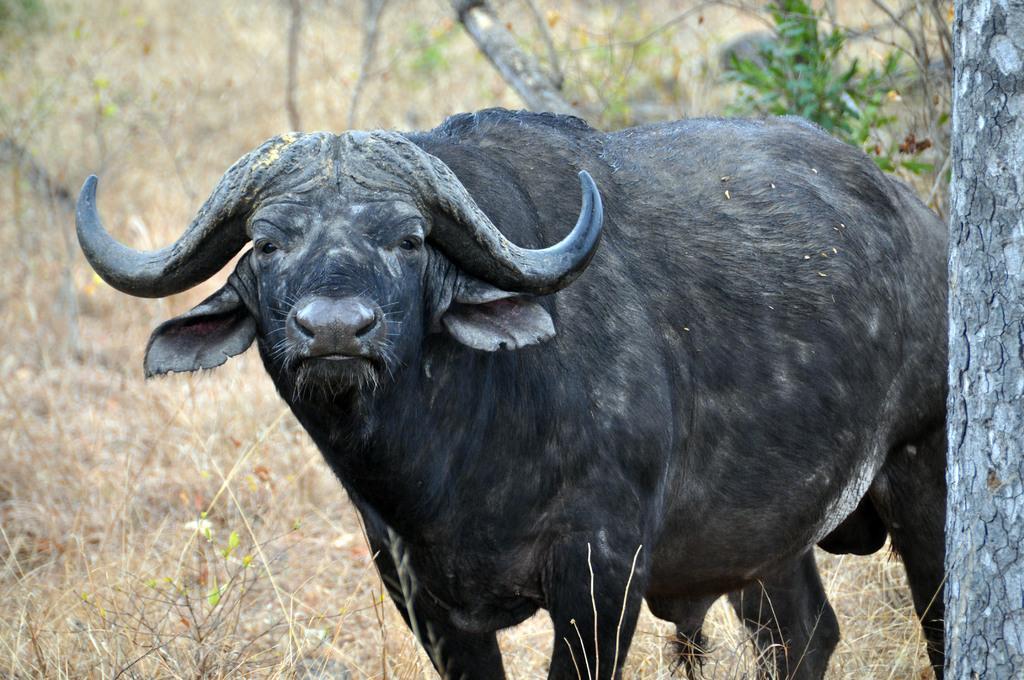In one or two sentences, can you explain what this image depicts? In this image I can see an animal which is black in color is standing on the ground. I can see few plants which are brown in color. In the background I can see a plant which is green in color and a tree. 